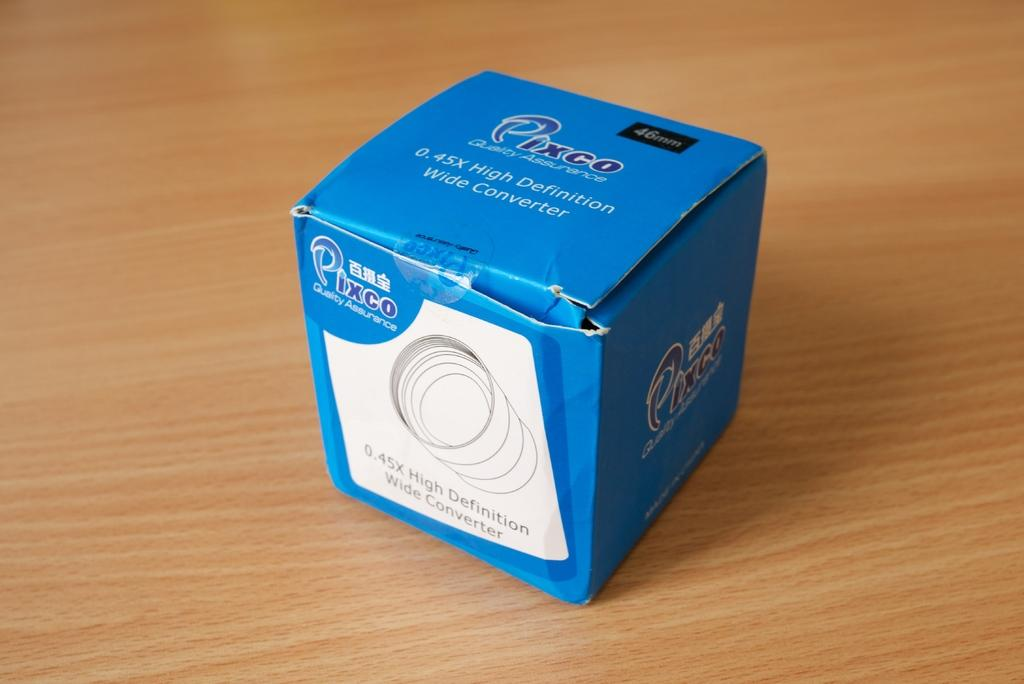<image>
Relay a brief, clear account of the picture shown. A wide converter box is blue and has the brand name Pixco on it. 